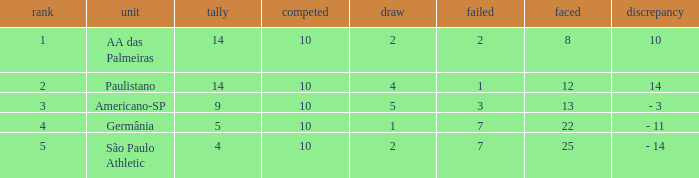I'm looking to parse the entire table for insights. Could you assist me with that? {'header': ['rank', 'unit', 'tally', 'competed', 'draw', 'failed', 'faced', 'discrepancy'], 'rows': [['1', 'AA das Palmeiras', '14', '10', '2', '2', '8', '10'], ['2', 'Paulistano', '14', '10', '4', '1', '12', '14'], ['3', 'Americano-SP', '9', '10', '5', '3', '13', '- 3'], ['4', 'Germânia', '5', '10', '1', '7', '22', '- 11'], ['5', 'São Paulo Athletic', '4', '10', '2', '7', '25', '- 14']]} What is the sum of Against when the lost is more than 7? None. 